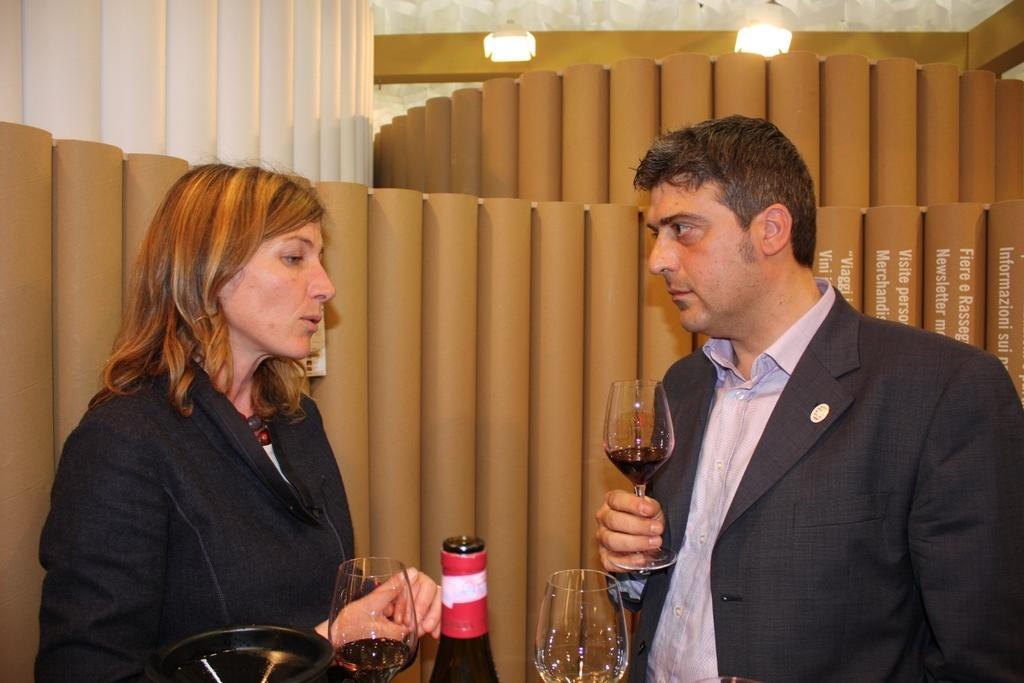Who is present in the image? There is a woman and a man in the image. What are the woman and man holding in the image? The woman and man are each holding a wine glass. What else can be seen in the image related to wine? There is a glass bottle and a wine glass in front of the couple. What type of badge is the man wearing in the image? There is no badge visible on the man in the image. How many men are present in the image? There is only one man present in the image. 